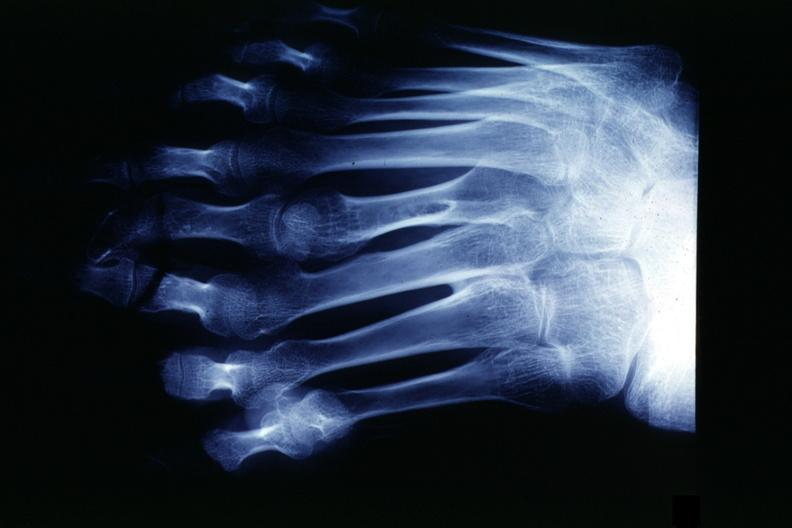what are present?
Answer the question using a single word or phrase. Extremities 